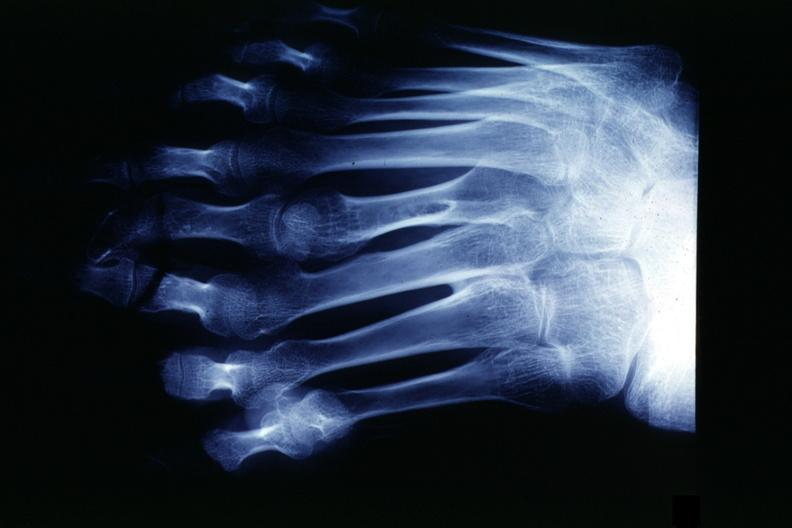what are present?
Answer the question using a single word or phrase. Extremities 